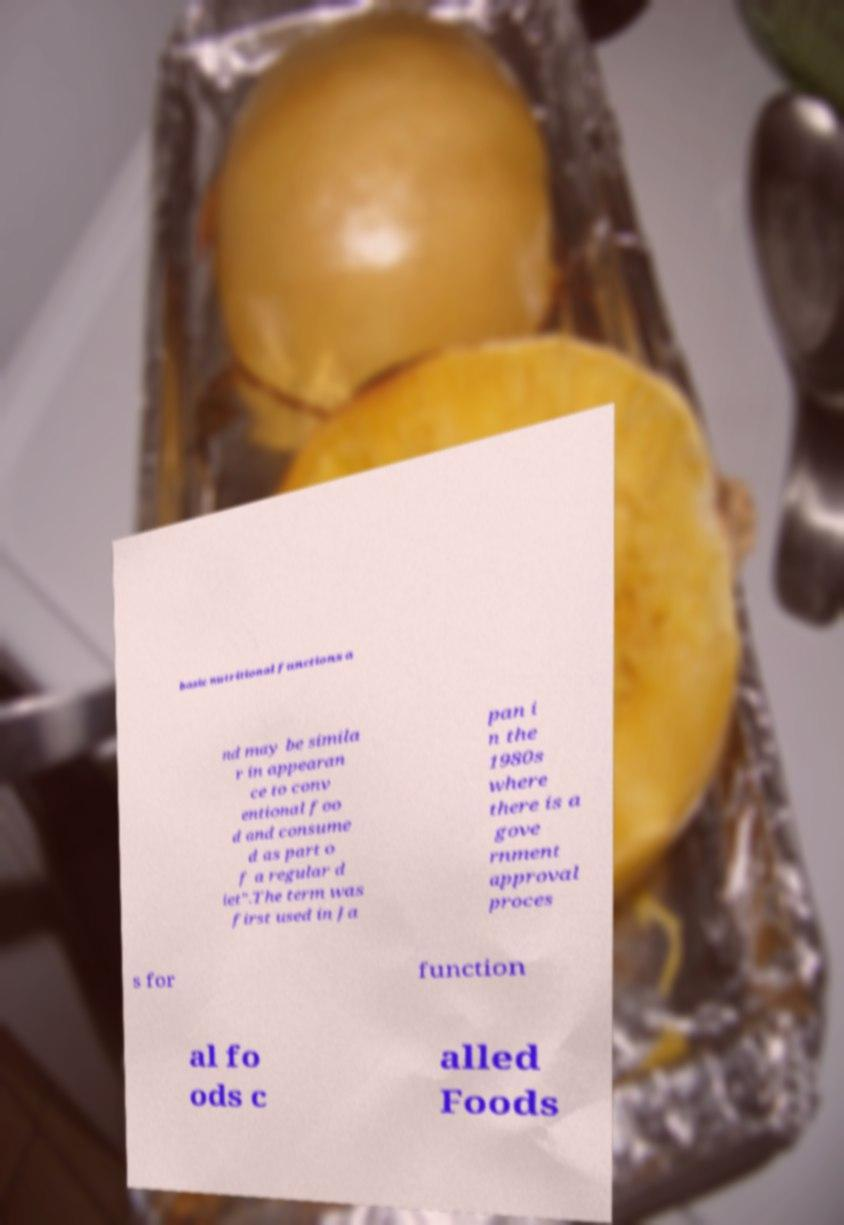What messages or text are displayed in this image? I need them in a readable, typed format. basic nutritional functions a nd may be simila r in appearan ce to conv entional foo d and consume d as part o f a regular d iet".The term was first used in Ja pan i n the 1980s where there is a gove rnment approval proces s for function al fo ods c alled Foods 